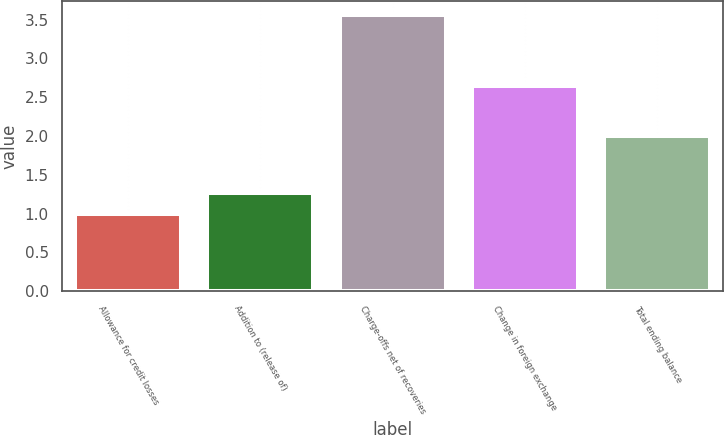Convert chart to OTSL. <chart><loc_0><loc_0><loc_500><loc_500><bar_chart><fcel>Allowance for credit losses<fcel>Addition to (release of)<fcel>Charge-offs net of recoveries<fcel>Change in foreign exchange<fcel>Total ending balance<nl><fcel>1<fcel>1.26<fcel>3.56<fcel>2.64<fcel>2<nl></chart> 